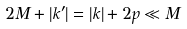<formula> <loc_0><loc_0><loc_500><loc_500>2 M + | k ^ { \prime } | = | k | + 2 p \ll M</formula> 